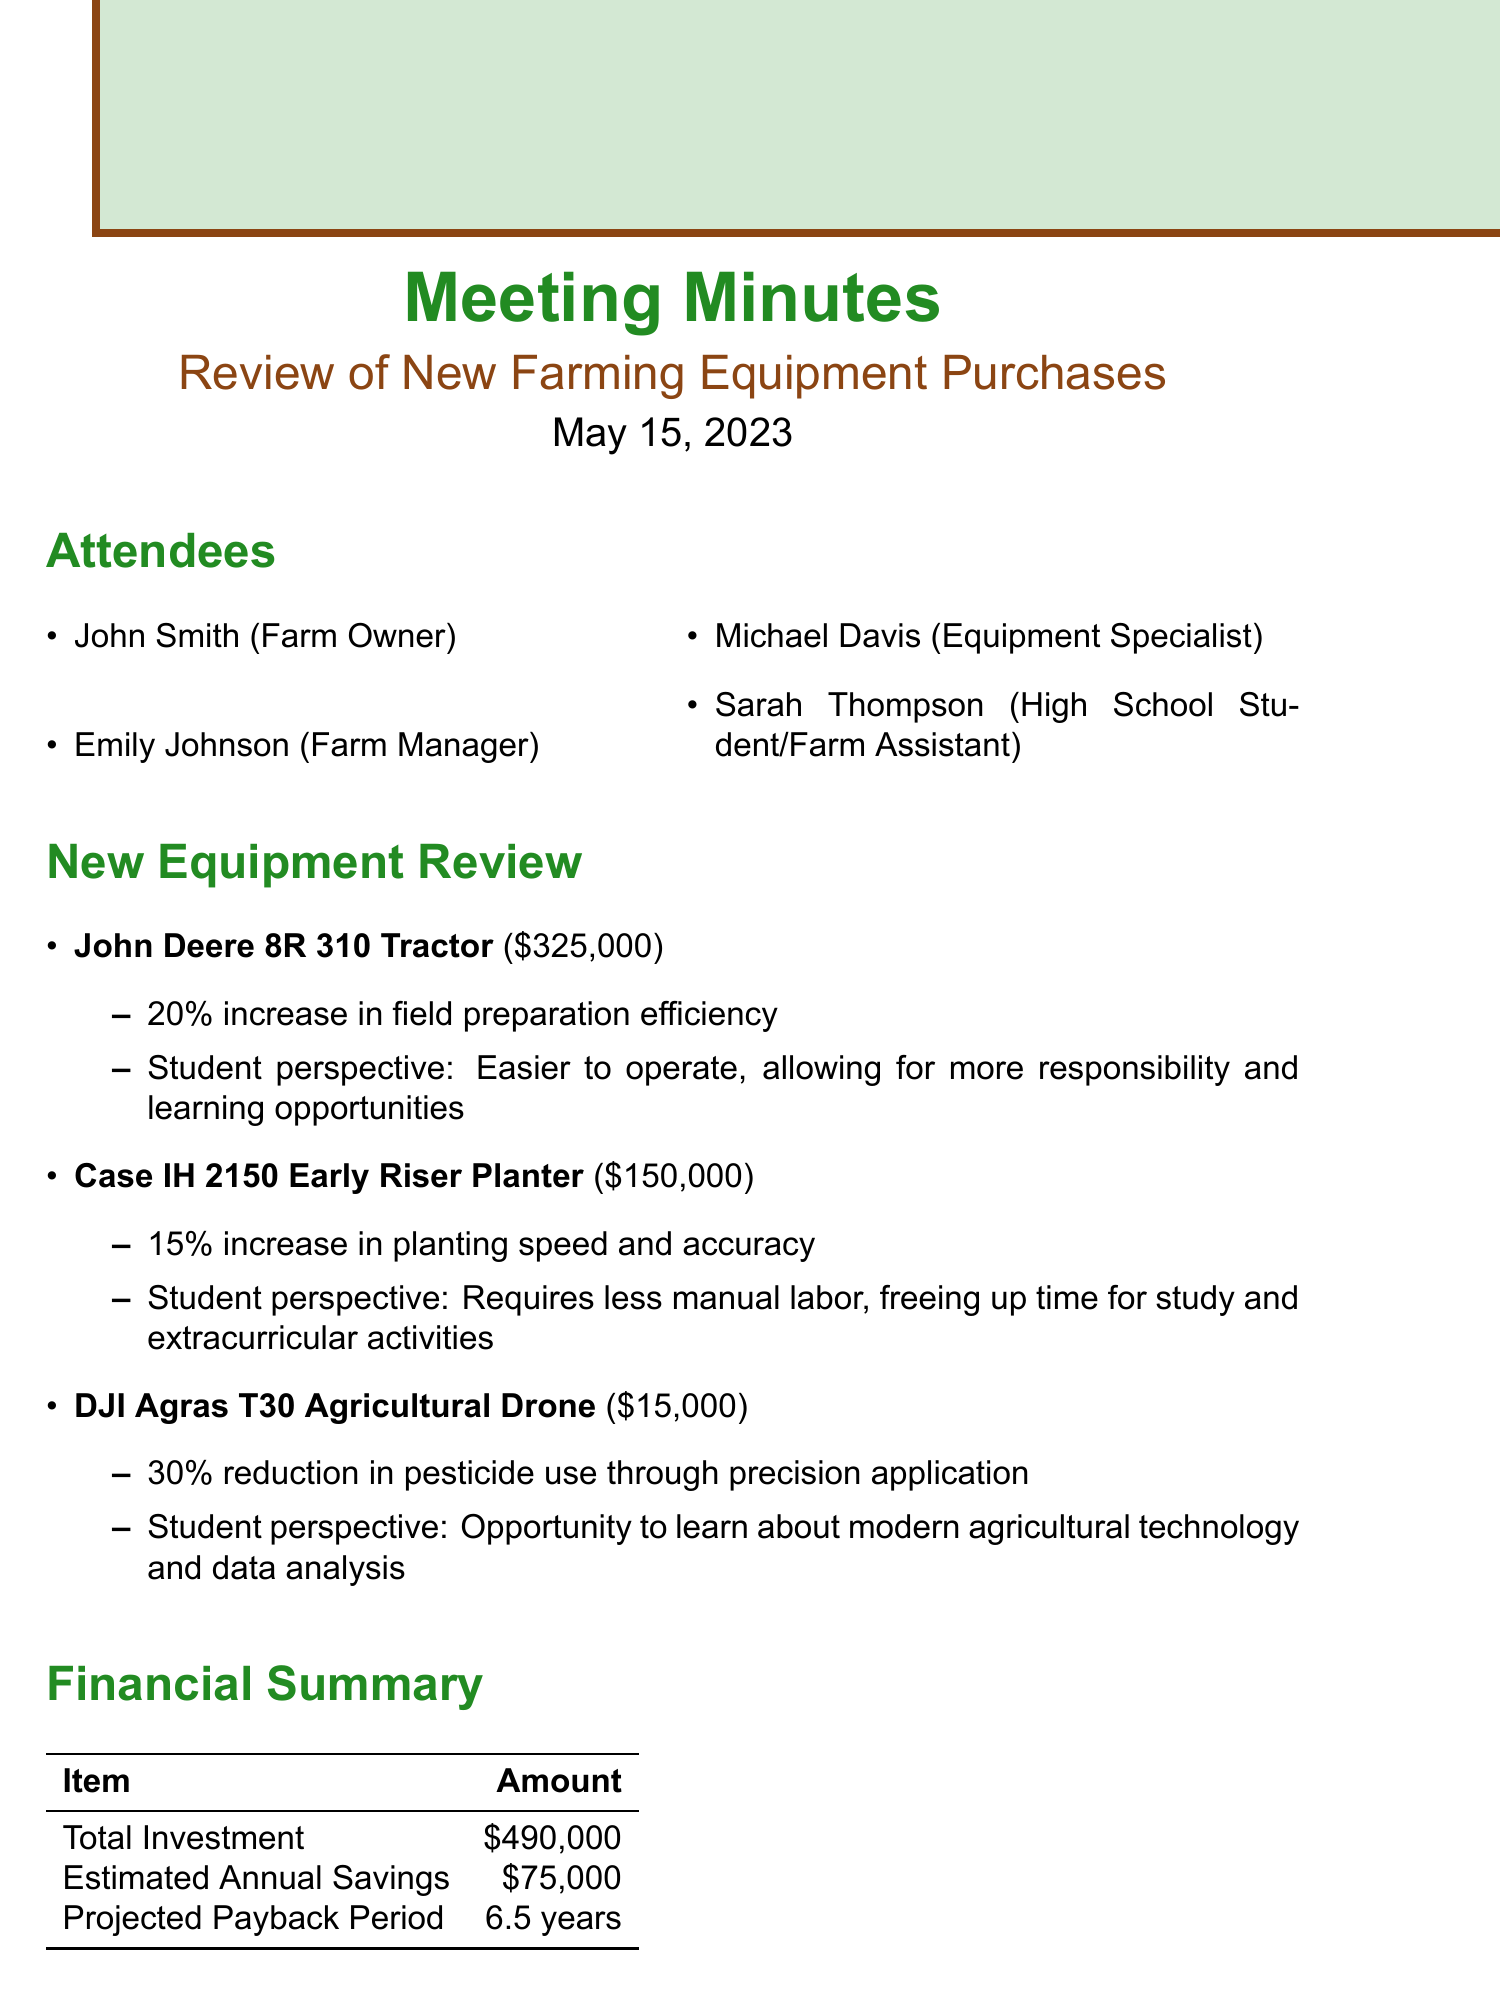What is the date of the meeting? The date of the meeting is listed in the document, which indicates when it took place.
Answer: May 15, 2023 Who is the Equipment Specialist present at the meeting? The document specifies the attendees and their roles, identifying who attended.
Answer: Michael Davis What is the cost of the John Deere 8R 310 Tractor? The specific cost of the John Deere 8R 310 Tractor is mentioned in the equipment review section of the document.
Answer: $325,000 What is the expected productivity improvement for the DJI Agras T30 Agricultural Drone? This information can be found under the review of the equipment, highlighting its efficiency benefits.
Answer: 30% reduction in pesticide use through precision application What are the estimated annual savings from the new equipment? The document provides a financial summary that includes estimated annual savings.
Answer: $75,000 Why might the Case IH 2150 Early Riser Planter be beneficial for students? The student perspective section of the document gives insights into benefits for students working with this equipment.
Answer: Requires less manual labor, freeing up time for study and extracurricular activities What is the total investment for the new equipment? The financial summary includes a total investment figure for new purchases made during the meeting.
Answer: $490,000 What is one action item from the meeting? The document lists action items that were agreed upon during the meeting.
Answer: Schedule training sessions for new equipment operation 